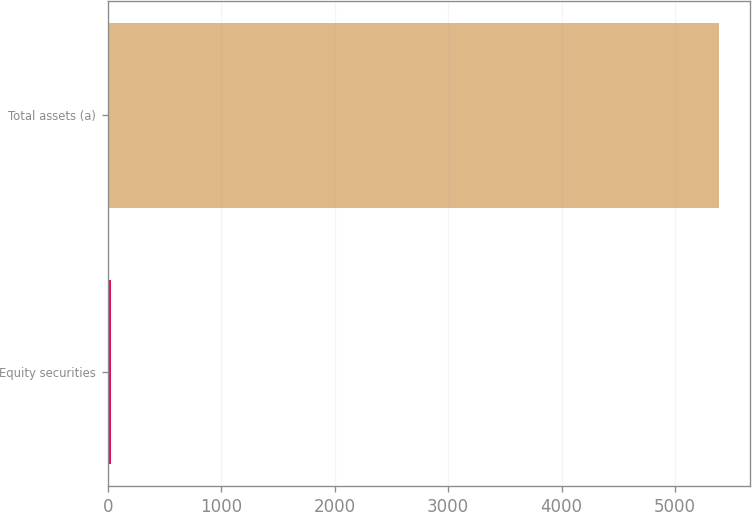Convert chart. <chart><loc_0><loc_0><loc_500><loc_500><bar_chart><fcel>Equity securities<fcel>Total assets (a)<nl><fcel>27<fcel>5388<nl></chart> 